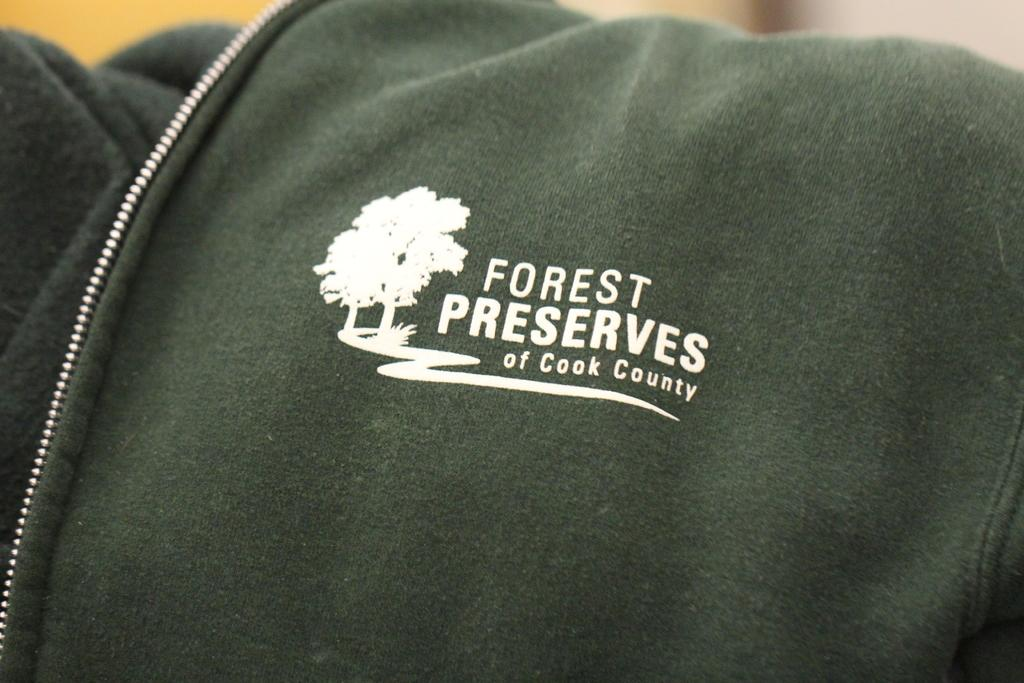What type of clothing item is in the image? There is a coat in the image. What distinguishing feature can be seen on the coat? The coat has a logo on it. Are there any words on the coat? Yes, there is writing on the coat. What type of fastener is on the coat? The coat has a metal zip. What can be seen in the background of the image? Trees are visible in the image. What type of battle is taking place in the image? There is no battle present in the image; it features a coat with a logo, writing, and a metal zip, along with trees in the background. 